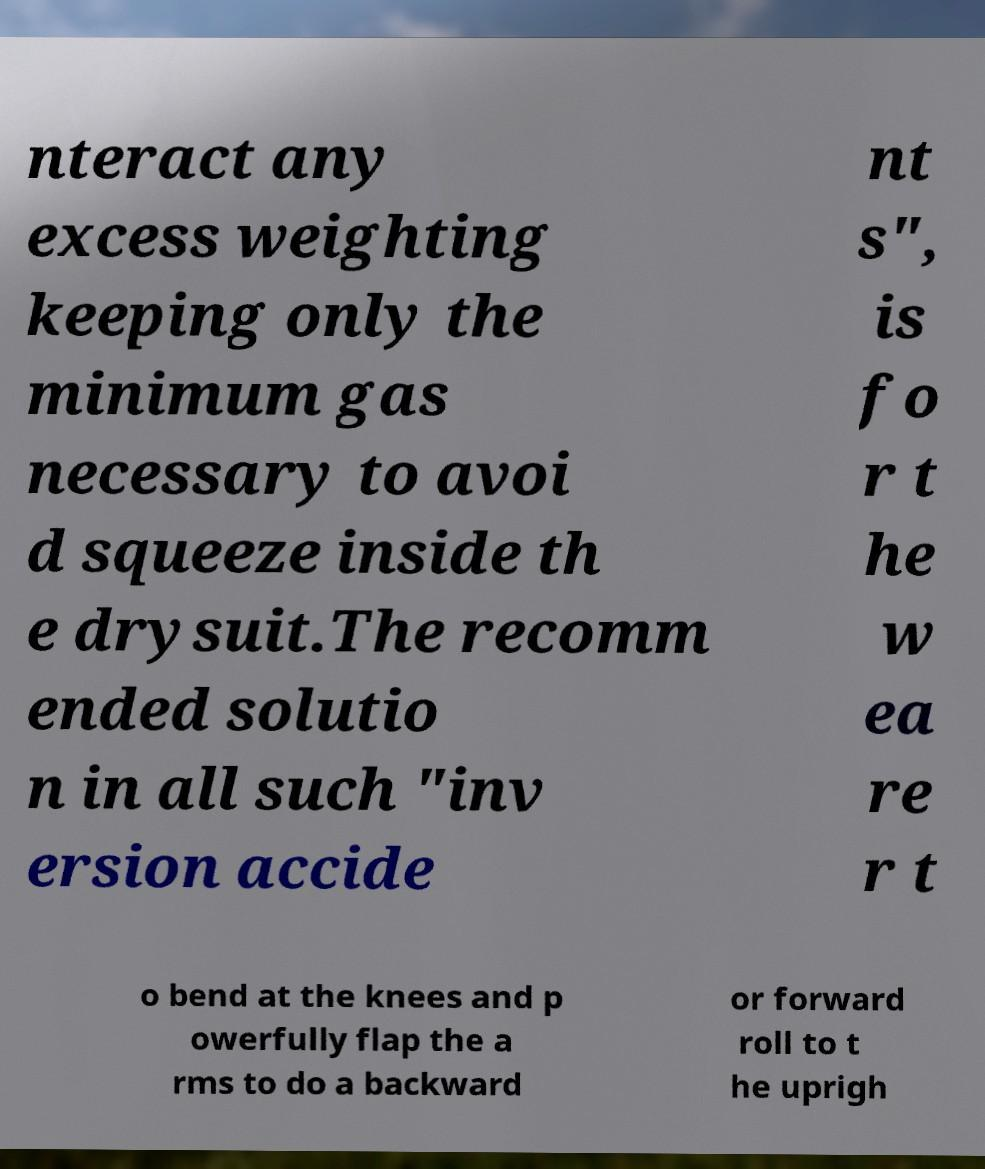What messages or text are displayed in this image? I need them in a readable, typed format. nteract any excess weighting keeping only the minimum gas necessary to avoi d squeeze inside th e drysuit.The recomm ended solutio n in all such "inv ersion accide nt s", is fo r t he w ea re r t o bend at the knees and p owerfully flap the a rms to do a backward or forward roll to t he uprigh 